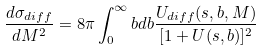Convert formula to latex. <formula><loc_0><loc_0><loc_500><loc_500>\frac { d \sigma _ { d i f f } } { d M ^ { 2 } } = 8 \pi \int ^ { \infty } _ { 0 } b d b \frac { U _ { d i f f } ( s , b , M ) } { [ 1 + U ( s , b ) ] ^ { 2 } }</formula> 